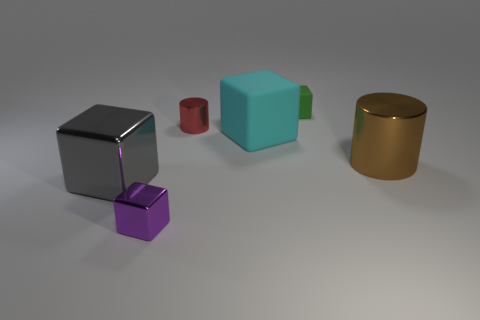What material is the tiny block that is behind the large block in front of the metal object that is to the right of the tiny red metallic thing made of?
Your response must be concise. Rubber. Does the tiny red thing have the same shape as the small green object?
Give a very brief answer. No. There is a cyan object that is the same shape as the tiny green rubber thing; what material is it?
Make the answer very short. Rubber. What number of large metallic cylinders are the same color as the large metallic cube?
Provide a succinct answer. 0. What is the size of the red thing that is made of the same material as the big brown object?
Your answer should be very brief. Small. How many cyan objects are either cylinders or metal things?
Provide a short and direct response. 0. What number of brown cylinders are to the right of the small object that is in front of the big gray cube?
Offer a very short reply. 1. Are there more cyan objects that are behind the small green matte cube than big rubber things behind the cyan object?
Provide a succinct answer. No. What is the material of the cyan thing?
Give a very brief answer. Rubber. Is there a shiny ball that has the same size as the cyan rubber cube?
Your answer should be compact. No. 